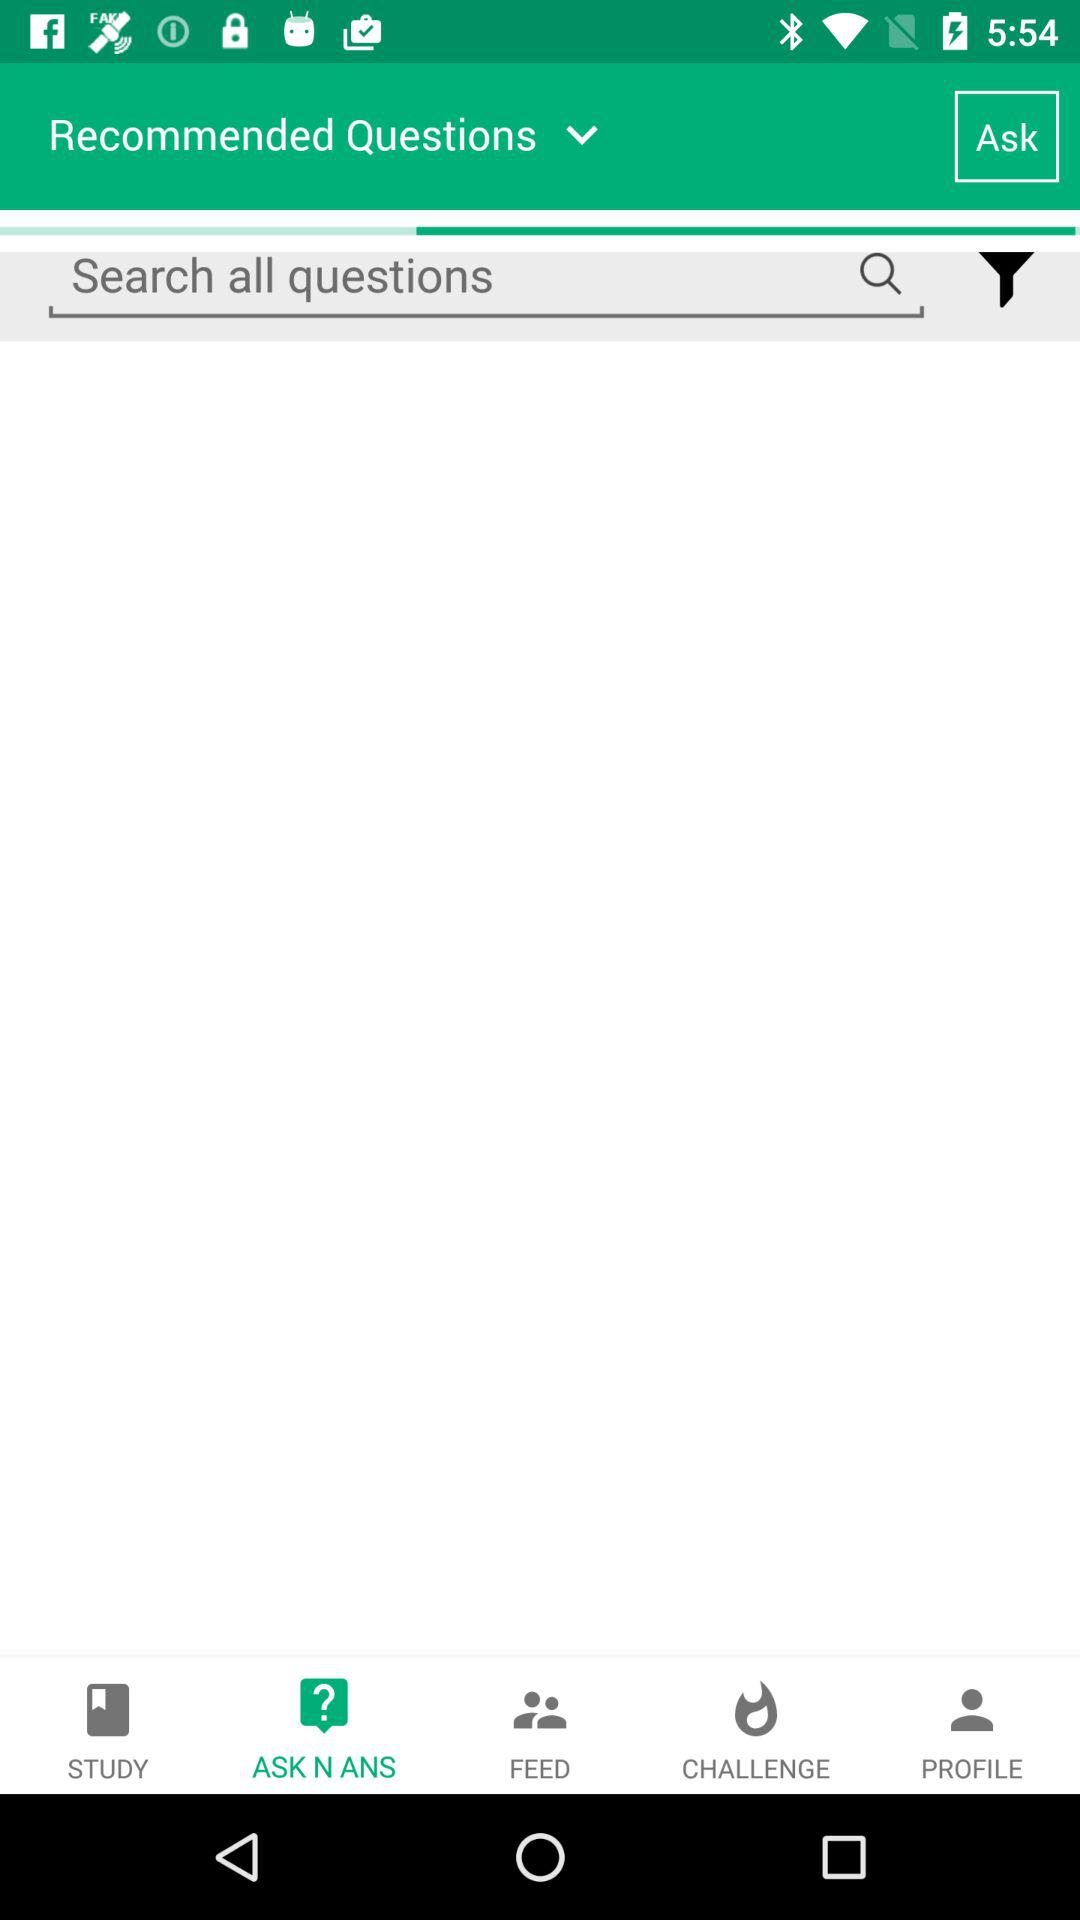Which tab is selected? The selected tab is "ASK N ANS". 